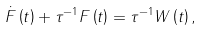<formula> <loc_0><loc_0><loc_500><loc_500>\dot { F } \left ( t \right ) + \tau ^ { - 1 } F \left ( t \right ) = \tau ^ { - 1 } W \left ( t \right ) ,</formula> 